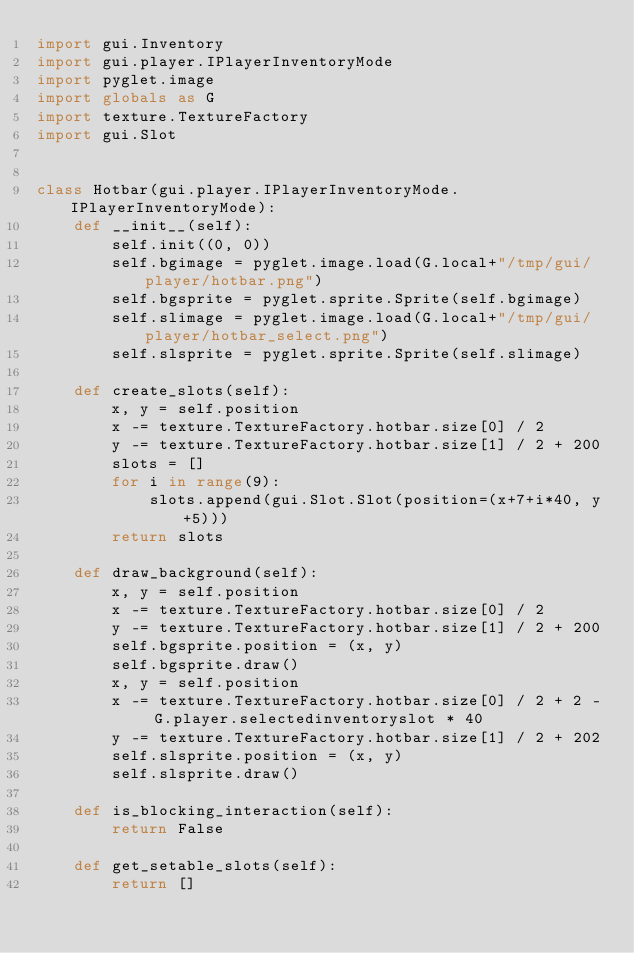<code> <loc_0><loc_0><loc_500><loc_500><_Python_>import gui.Inventory
import gui.player.IPlayerInventoryMode
import pyglet.image
import globals as G
import texture.TextureFactory
import gui.Slot


class Hotbar(gui.player.IPlayerInventoryMode.IPlayerInventoryMode):
    def __init__(self):
        self.init((0, 0))
        self.bgimage = pyglet.image.load(G.local+"/tmp/gui/player/hotbar.png")
        self.bgsprite = pyglet.sprite.Sprite(self.bgimage)
        self.slimage = pyglet.image.load(G.local+"/tmp/gui/player/hotbar_select.png")
        self.slsprite = pyglet.sprite.Sprite(self.slimage)

    def create_slots(self):
        x, y = self.position
        x -= texture.TextureFactory.hotbar.size[0] / 2
        y -= texture.TextureFactory.hotbar.size[1] / 2 + 200
        slots = []
        for i in range(9):
            slots.append(gui.Slot.Slot(position=(x+7+i*40, y+5)))
        return slots

    def draw_background(self):
        x, y = self.position
        x -= texture.TextureFactory.hotbar.size[0] / 2
        y -= texture.TextureFactory.hotbar.size[1] / 2 + 200
        self.bgsprite.position = (x, y)
        self.bgsprite.draw()
        x, y = self.position
        x -= texture.TextureFactory.hotbar.size[0] / 2 + 2 - G.player.selectedinventoryslot * 40
        y -= texture.TextureFactory.hotbar.size[1] / 2 + 202
        self.slsprite.position = (x, y)
        self.slsprite.draw()

    def is_blocking_interaction(self):
        return False

    def get_setable_slots(self):
        return []

</code> 